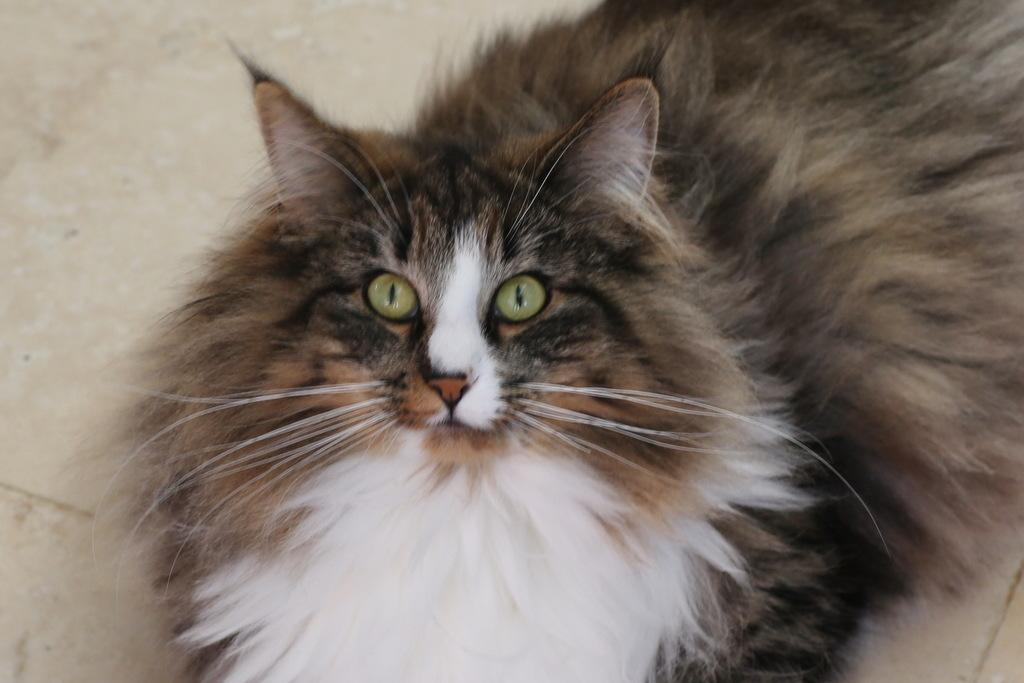What type of animal is in the image? There is a cat in the image. Can you describe the color pattern of the cat? The cat has a white and black color combination. Where is the cat located in the image? The cat is on the floor. How many snakes are present in the image? There are no snakes present in the image; it features a cat on the floor. What type of ghost can be seen interacting with the cat in the image? There is no ghost present in the image; it only features a cat on the floor. 